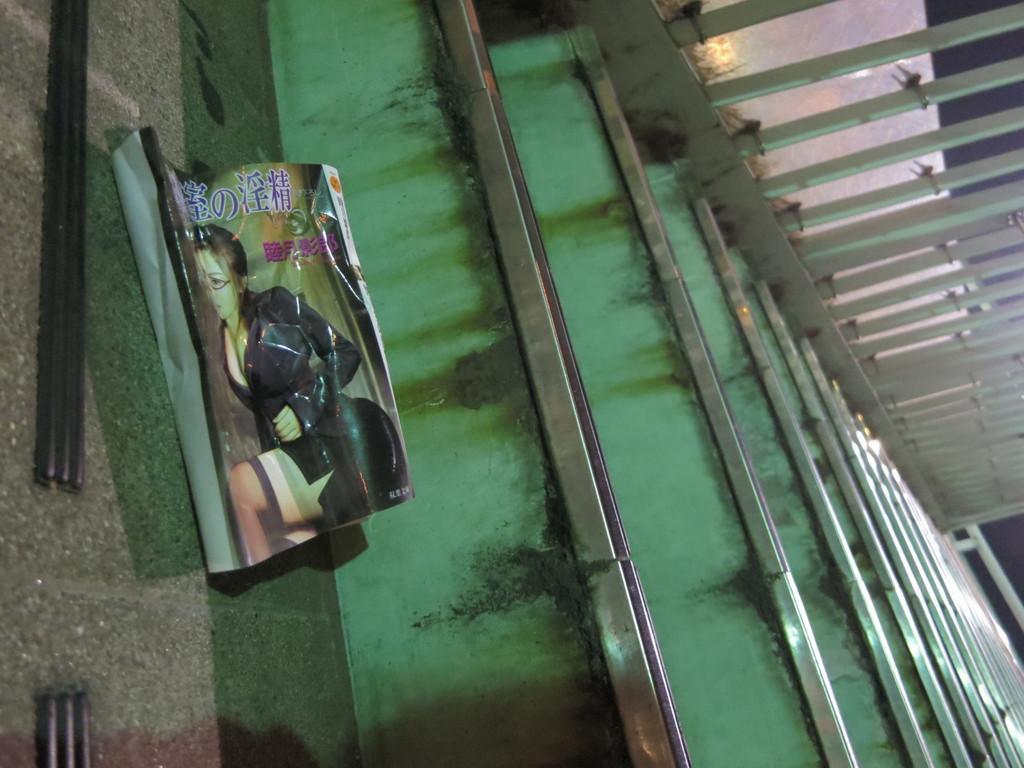In one or two sentences, can you explain what this image depicts? In this image we can see a cover on the stairs. On the right side we can see the railing. 